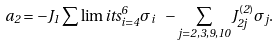Convert formula to latex. <formula><loc_0><loc_0><loc_500><loc_500>a _ { 2 } = - J _ { 1 } \sum \lim i t s _ { i = 4 } ^ { 6 } \sigma _ { i } \ - \sum _ { j = 2 , 3 , 9 , 1 0 } J _ { 2 j } ^ { ( 2 ) } \sigma _ { j } .</formula> 